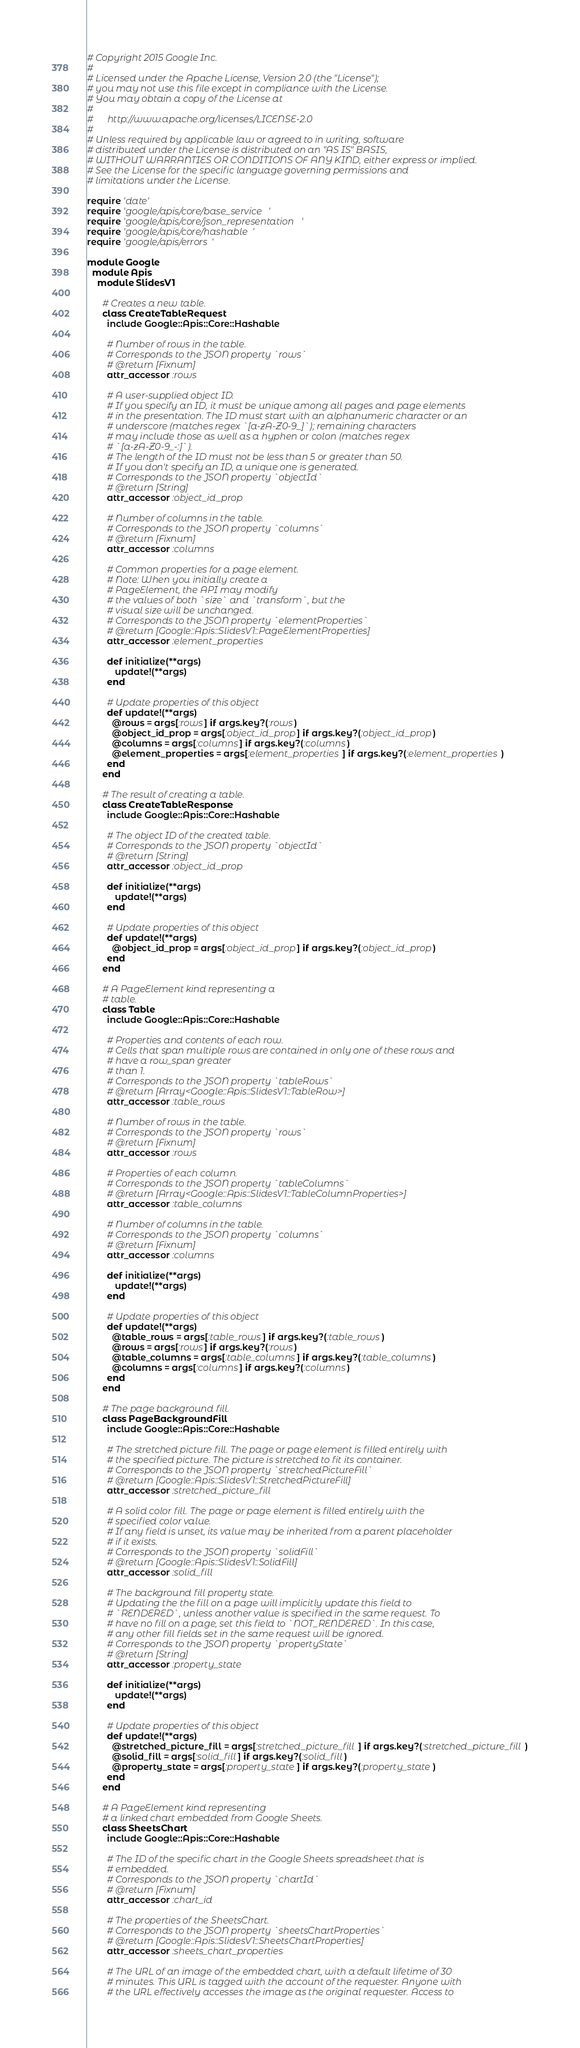<code> <loc_0><loc_0><loc_500><loc_500><_Ruby_># Copyright 2015 Google Inc.
#
# Licensed under the Apache License, Version 2.0 (the "License");
# you may not use this file except in compliance with the License.
# You may obtain a copy of the License at
#
#      http://www.apache.org/licenses/LICENSE-2.0
#
# Unless required by applicable law or agreed to in writing, software
# distributed under the License is distributed on an "AS IS" BASIS,
# WITHOUT WARRANTIES OR CONDITIONS OF ANY KIND, either express or implied.
# See the License for the specific language governing permissions and
# limitations under the License.

require 'date'
require 'google/apis/core/base_service'
require 'google/apis/core/json_representation'
require 'google/apis/core/hashable'
require 'google/apis/errors'

module Google
  module Apis
    module SlidesV1
      
      # Creates a new table.
      class CreateTableRequest
        include Google::Apis::Core::Hashable
      
        # Number of rows in the table.
        # Corresponds to the JSON property `rows`
        # @return [Fixnum]
        attr_accessor :rows
      
        # A user-supplied object ID.
        # If you specify an ID, it must be unique among all pages and page elements
        # in the presentation. The ID must start with an alphanumeric character or an
        # underscore (matches regex `[a-zA-Z0-9_]`); remaining characters
        # may include those as well as a hyphen or colon (matches regex
        # `[a-zA-Z0-9_-:]`).
        # The length of the ID must not be less than 5 or greater than 50.
        # If you don't specify an ID, a unique one is generated.
        # Corresponds to the JSON property `objectId`
        # @return [String]
        attr_accessor :object_id_prop
      
        # Number of columns in the table.
        # Corresponds to the JSON property `columns`
        # @return [Fixnum]
        attr_accessor :columns
      
        # Common properties for a page element.
        # Note: When you initially create a
        # PageElement, the API may modify
        # the values of both `size` and `transform`, but the
        # visual size will be unchanged.
        # Corresponds to the JSON property `elementProperties`
        # @return [Google::Apis::SlidesV1::PageElementProperties]
        attr_accessor :element_properties
      
        def initialize(**args)
           update!(**args)
        end
      
        # Update properties of this object
        def update!(**args)
          @rows = args[:rows] if args.key?(:rows)
          @object_id_prop = args[:object_id_prop] if args.key?(:object_id_prop)
          @columns = args[:columns] if args.key?(:columns)
          @element_properties = args[:element_properties] if args.key?(:element_properties)
        end
      end
      
      # The result of creating a table.
      class CreateTableResponse
        include Google::Apis::Core::Hashable
      
        # The object ID of the created table.
        # Corresponds to the JSON property `objectId`
        # @return [String]
        attr_accessor :object_id_prop
      
        def initialize(**args)
           update!(**args)
        end
      
        # Update properties of this object
        def update!(**args)
          @object_id_prop = args[:object_id_prop] if args.key?(:object_id_prop)
        end
      end
      
      # A PageElement kind representing a
      # table.
      class Table
        include Google::Apis::Core::Hashable
      
        # Properties and contents of each row.
        # Cells that span multiple rows are contained in only one of these rows and
        # have a row_span greater
        # than 1.
        # Corresponds to the JSON property `tableRows`
        # @return [Array<Google::Apis::SlidesV1::TableRow>]
        attr_accessor :table_rows
      
        # Number of rows in the table.
        # Corresponds to the JSON property `rows`
        # @return [Fixnum]
        attr_accessor :rows
      
        # Properties of each column.
        # Corresponds to the JSON property `tableColumns`
        # @return [Array<Google::Apis::SlidesV1::TableColumnProperties>]
        attr_accessor :table_columns
      
        # Number of columns in the table.
        # Corresponds to the JSON property `columns`
        # @return [Fixnum]
        attr_accessor :columns
      
        def initialize(**args)
           update!(**args)
        end
      
        # Update properties of this object
        def update!(**args)
          @table_rows = args[:table_rows] if args.key?(:table_rows)
          @rows = args[:rows] if args.key?(:rows)
          @table_columns = args[:table_columns] if args.key?(:table_columns)
          @columns = args[:columns] if args.key?(:columns)
        end
      end
      
      # The page background fill.
      class PageBackgroundFill
        include Google::Apis::Core::Hashable
      
        # The stretched picture fill. The page or page element is filled entirely with
        # the specified picture. The picture is stretched to fit its container.
        # Corresponds to the JSON property `stretchedPictureFill`
        # @return [Google::Apis::SlidesV1::StretchedPictureFill]
        attr_accessor :stretched_picture_fill
      
        # A solid color fill. The page or page element is filled entirely with the
        # specified color value.
        # If any field is unset, its value may be inherited from a parent placeholder
        # if it exists.
        # Corresponds to the JSON property `solidFill`
        # @return [Google::Apis::SlidesV1::SolidFill]
        attr_accessor :solid_fill
      
        # The background fill property state.
        # Updating the the fill on a page will implicitly update this field to
        # `RENDERED`, unless another value is specified in the same request. To
        # have no fill on a page, set this field to `NOT_RENDERED`. In this case,
        # any other fill fields set in the same request will be ignored.
        # Corresponds to the JSON property `propertyState`
        # @return [String]
        attr_accessor :property_state
      
        def initialize(**args)
           update!(**args)
        end
      
        # Update properties of this object
        def update!(**args)
          @stretched_picture_fill = args[:stretched_picture_fill] if args.key?(:stretched_picture_fill)
          @solid_fill = args[:solid_fill] if args.key?(:solid_fill)
          @property_state = args[:property_state] if args.key?(:property_state)
        end
      end
      
      # A PageElement kind representing
      # a linked chart embedded from Google Sheets.
      class SheetsChart
        include Google::Apis::Core::Hashable
      
        # The ID of the specific chart in the Google Sheets spreadsheet that is
        # embedded.
        # Corresponds to the JSON property `chartId`
        # @return [Fixnum]
        attr_accessor :chart_id
      
        # The properties of the SheetsChart.
        # Corresponds to the JSON property `sheetsChartProperties`
        # @return [Google::Apis::SlidesV1::SheetsChartProperties]
        attr_accessor :sheets_chart_properties
      
        # The URL of an image of the embedded chart, with a default lifetime of 30
        # minutes. This URL is tagged with the account of the requester. Anyone with
        # the URL effectively accesses the image as the original requester. Access to</code> 